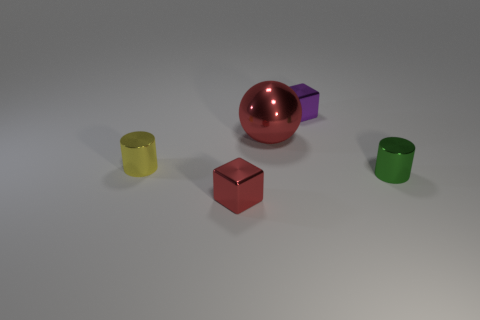There is another thing that is the same color as the big metallic object; what is its shape?
Make the answer very short. Cube. Does the purple cube have the same size as the red sphere?
Your answer should be compact. No. Is there anything else that has the same size as the metal sphere?
Make the answer very short. No. There is a big ball that is the same material as the tiny yellow cylinder; what color is it?
Provide a succinct answer. Red. Is the number of tiny red objects that are to the right of the green metallic object less than the number of objects behind the tiny red cube?
Your answer should be very brief. Yes. How many other shiny spheres have the same color as the big sphere?
Keep it short and to the point. 0. What number of small metallic objects are both in front of the sphere and right of the red cube?
Provide a succinct answer. 1. Is there a purple cube made of the same material as the yellow cylinder?
Offer a terse response. Yes. What is the size of the red metal object that is behind the yellow metal cylinder on the left side of the shiny block behind the tiny red metallic block?
Your answer should be compact. Large. Are there any small purple metal things on the right side of the small metal block to the right of the tiny red metallic thing?
Make the answer very short. No. 